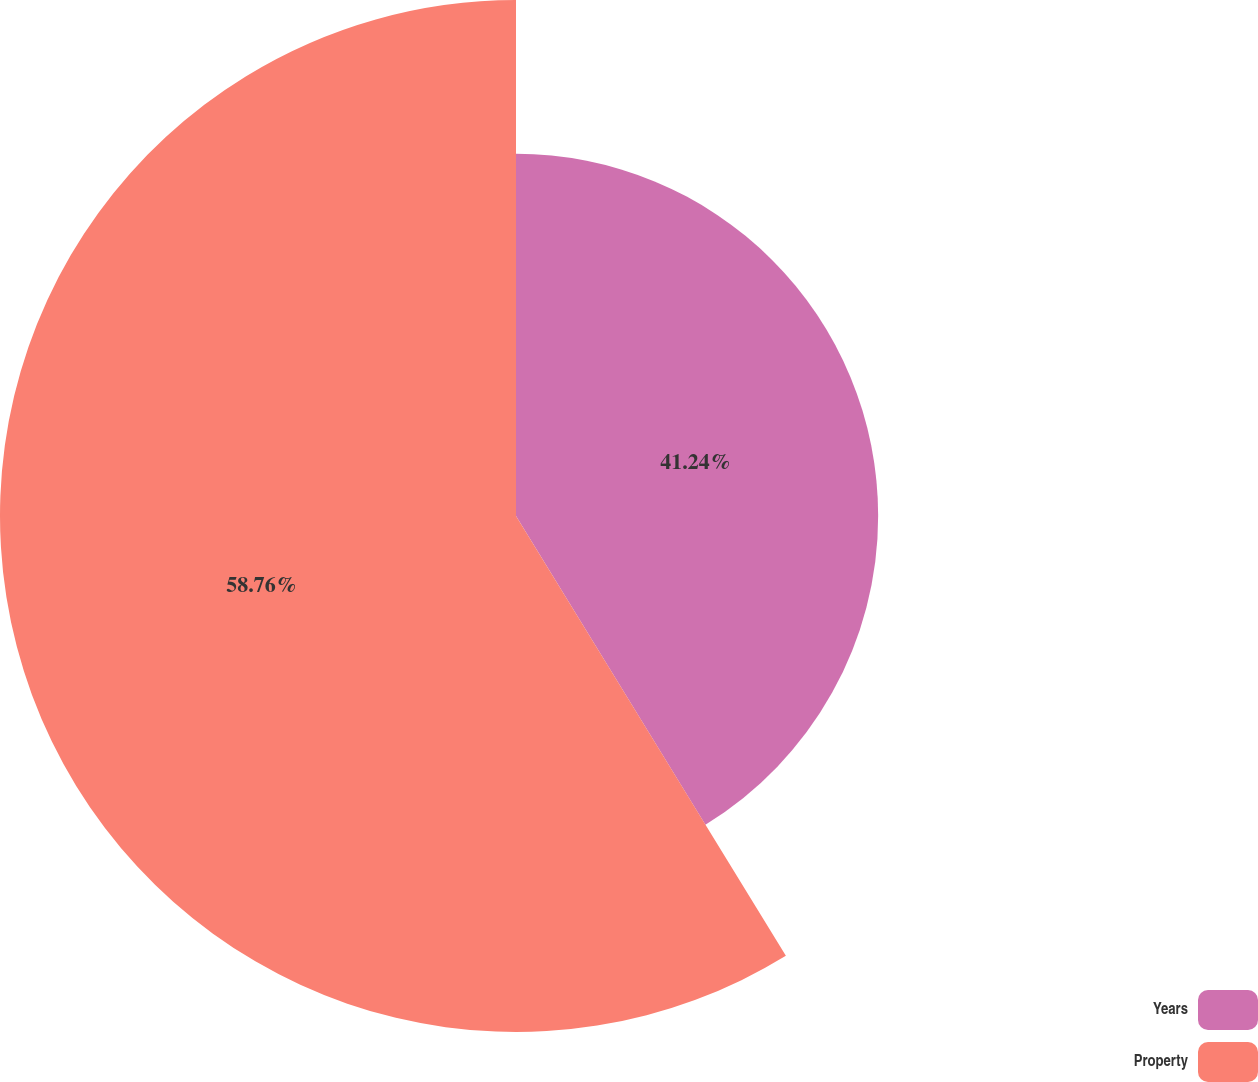Convert chart. <chart><loc_0><loc_0><loc_500><loc_500><pie_chart><fcel>Years<fcel>Property<nl><fcel>41.24%<fcel>58.76%<nl></chart> 